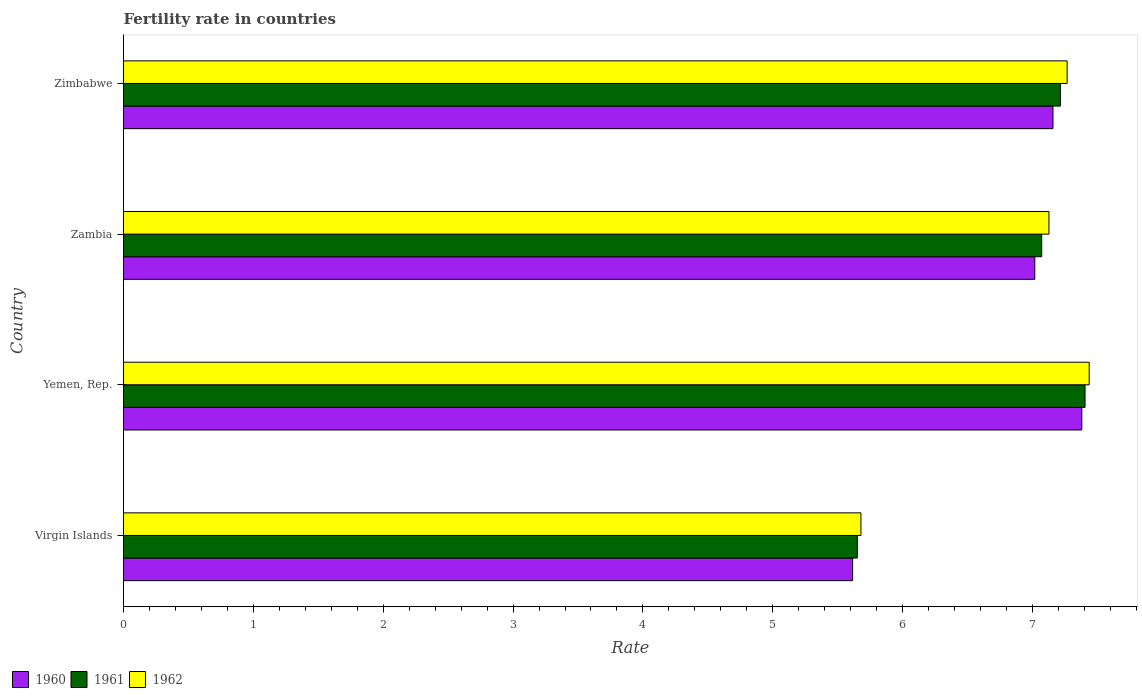How many different coloured bars are there?
Provide a short and direct response. 3. How many groups of bars are there?
Your answer should be compact. 4. Are the number of bars per tick equal to the number of legend labels?
Ensure brevity in your answer.  Yes. How many bars are there on the 4th tick from the top?
Your answer should be very brief. 3. How many bars are there on the 3rd tick from the bottom?
Keep it short and to the point. 3. What is the label of the 4th group of bars from the top?
Give a very brief answer. Virgin Islands. In how many cases, is the number of bars for a given country not equal to the number of legend labels?
Provide a short and direct response. 0. What is the fertility rate in 1962 in Yemen, Rep.?
Your response must be concise. 7.44. Across all countries, what is the maximum fertility rate in 1960?
Offer a terse response. 7.38. Across all countries, what is the minimum fertility rate in 1962?
Provide a succinct answer. 5.68. In which country was the fertility rate in 1961 maximum?
Your answer should be very brief. Yemen, Rep. In which country was the fertility rate in 1960 minimum?
Ensure brevity in your answer.  Virgin Islands. What is the total fertility rate in 1962 in the graph?
Provide a short and direct response. 27.51. What is the difference between the fertility rate in 1960 in Zambia and that in Zimbabwe?
Provide a short and direct response. -0.14. What is the difference between the fertility rate in 1962 in Virgin Islands and the fertility rate in 1960 in Zimbabwe?
Your answer should be compact. -1.48. What is the average fertility rate in 1960 per country?
Offer a very short reply. 6.79. What is the difference between the fertility rate in 1962 and fertility rate in 1960 in Virgin Islands?
Provide a succinct answer. 0.06. In how many countries, is the fertility rate in 1961 greater than 3.4 ?
Offer a terse response. 4. What is the ratio of the fertility rate in 1960 in Yemen, Rep. to that in Zimbabwe?
Your answer should be very brief. 1.03. Is the fertility rate in 1961 in Zambia less than that in Zimbabwe?
Your answer should be very brief. Yes. What is the difference between the highest and the second highest fertility rate in 1961?
Your answer should be compact. 0.19. What is the difference between the highest and the lowest fertility rate in 1961?
Provide a succinct answer. 1.75. In how many countries, is the fertility rate in 1961 greater than the average fertility rate in 1961 taken over all countries?
Your response must be concise. 3. What does the 3rd bar from the bottom in Yemen, Rep. represents?
Give a very brief answer. 1962. Is it the case that in every country, the sum of the fertility rate in 1960 and fertility rate in 1962 is greater than the fertility rate in 1961?
Give a very brief answer. Yes. Are all the bars in the graph horizontal?
Make the answer very short. Yes. Does the graph contain any zero values?
Keep it short and to the point. No. What is the title of the graph?
Make the answer very short. Fertility rate in countries. What is the label or title of the X-axis?
Make the answer very short. Rate. What is the label or title of the Y-axis?
Your response must be concise. Country. What is the Rate in 1960 in Virgin Islands?
Give a very brief answer. 5.62. What is the Rate in 1961 in Virgin Islands?
Your response must be concise. 5.65. What is the Rate of 1962 in Virgin Islands?
Ensure brevity in your answer.  5.68. What is the Rate in 1960 in Yemen, Rep.?
Your response must be concise. 7.38. What is the Rate in 1961 in Yemen, Rep.?
Ensure brevity in your answer.  7.41. What is the Rate of 1962 in Yemen, Rep.?
Make the answer very short. 7.44. What is the Rate in 1960 in Zambia?
Your response must be concise. 7.02. What is the Rate in 1961 in Zambia?
Provide a succinct answer. 7.07. What is the Rate in 1962 in Zambia?
Provide a short and direct response. 7.13. What is the Rate of 1960 in Zimbabwe?
Provide a succinct answer. 7.16. What is the Rate of 1961 in Zimbabwe?
Provide a short and direct response. 7.21. What is the Rate in 1962 in Zimbabwe?
Keep it short and to the point. 7.27. Across all countries, what is the maximum Rate of 1960?
Keep it short and to the point. 7.38. Across all countries, what is the maximum Rate of 1961?
Offer a very short reply. 7.41. Across all countries, what is the maximum Rate in 1962?
Provide a short and direct response. 7.44. Across all countries, what is the minimum Rate of 1960?
Provide a succinct answer. 5.62. Across all countries, what is the minimum Rate in 1961?
Keep it short and to the point. 5.65. Across all countries, what is the minimum Rate in 1962?
Provide a succinct answer. 5.68. What is the total Rate of 1960 in the graph?
Your answer should be compact. 27.17. What is the total Rate in 1961 in the graph?
Give a very brief answer. 27.34. What is the total Rate of 1962 in the graph?
Make the answer very short. 27.51. What is the difference between the Rate of 1960 in Virgin Islands and that in Yemen, Rep.?
Offer a very short reply. -1.76. What is the difference between the Rate of 1961 in Virgin Islands and that in Yemen, Rep.?
Provide a short and direct response. -1.75. What is the difference between the Rate of 1962 in Virgin Islands and that in Yemen, Rep.?
Give a very brief answer. -1.76. What is the difference between the Rate of 1960 in Virgin Islands and that in Zambia?
Give a very brief answer. -1.4. What is the difference between the Rate in 1961 in Virgin Islands and that in Zambia?
Provide a short and direct response. -1.42. What is the difference between the Rate of 1962 in Virgin Islands and that in Zambia?
Ensure brevity in your answer.  -1.45. What is the difference between the Rate in 1960 in Virgin Islands and that in Zimbabwe?
Your answer should be compact. -1.54. What is the difference between the Rate in 1961 in Virgin Islands and that in Zimbabwe?
Ensure brevity in your answer.  -1.56. What is the difference between the Rate in 1962 in Virgin Islands and that in Zimbabwe?
Keep it short and to the point. -1.59. What is the difference between the Rate of 1960 in Yemen, Rep. and that in Zambia?
Offer a very short reply. 0.36. What is the difference between the Rate in 1961 in Yemen, Rep. and that in Zambia?
Offer a terse response. 0.33. What is the difference between the Rate in 1962 in Yemen, Rep. and that in Zambia?
Offer a terse response. 0.31. What is the difference between the Rate in 1960 in Yemen, Rep. and that in Zimbabwe?
Provide a succinct answer. 0.22. What is the difference between the Rate in 1961 in Yemen, Rep. and that in Zimbabwe?
Your answer should be very brief. 0.19. What is the difference between the Rate in 1962 in Yemen, Rep. and that in Zimbabwe?
Offer a terse response. 0.17. What is the difference between the Rate of 1960 in Zambia and that in Zimbabwe?
Keep it short and to the point. -0.14. What is the difference between the Rate of 1961 in Zambia and that in Zimbabwe?
Your answer should be compact. -0.14. What is the difference between the Rate of 1962 in Zambia and that in Zimbabwe?
Ensure brevity in your answer.  -0.14. What is the difference between the Rate in 1960 in Virgin Islands and the Rate in 1961 in Yemen, Rep.?
Make the answer very short. -1.79. What is the difference between the Rate in 1960 in Virgin Islands and the Rate in 1962 in Yemen, Rep.?
Keep it short and to the point. -1.82. What is the difference between the Rate of 1961 in Virgin Islands and the Rate of 1962 in Yemen, Rep.?
Ensure brevity in your answer.  -1.79. What is the difference between the Rate in 1960 in Virgin Islands and the Rate in 1961 in Zambia?
Your response must be concise. -1.46. What is the difference between the Rate of 1960 in Virgin Islands and the Rate of 1962 in Zambia?
Your answer should be very brief. -1.51. What is the difference between the Rate of 1961 in Virgin Islands and the Rate of 1962 in Zambia?
Make the answer very short. -1.48. What is the difference between the Rate in 1960 in Virgin Islands and the Rate in 1962 in Zimbabwe?
Provide a succinct answer. -1.65. What is the difference between the Rate in 1961 in Virgin Islands and the Rate in 1962 in Zimbabwe?
Offer a very short reply. -1.62. What is the difference between the Rate of 1960 in Yemen, Rep. and the Rate of 1961 in Zambia?
Provide a short and direct response. 0.31. What is the difference between the Rate of 1960 in Yemen, Rep. and the Rate of 1962 in Zambia?
Offer a very short reply. 0.25. What is the difference between the Rate of 1961 in Yemen, Rep. and the Rate of 1962 in Zambia?
Your answer should be very brief. 0.28. What is the difference between the Rate of 1960 in Yemen, Rep. and the Rate of 1961 in Zimbabwe?
Give a very brief answer. 0.17. What is the difference between the Rate of 1960 in Yemen, Rep. and the Rate of 1962 in Zimbabwe?
Give a very brief answer. 0.11. What is the difference between the Rate of 1961 in Yemen, Rep. and the Rate of 1962 in Zimbabwe?
Your answer should be very brief. 0.14. What is the difference between the Rate of 1960 in Zambia and the Rate of 1961 in Zimbabwe?
Your answer should be very brief. -0.2. What is the difference between the Rate in 1960 in Zambia and the Rate in 1962 in Zimbabwe?
Provide a succinct answer. -0.25. What is the difference between the Rate of 1961 in Zambia and the Rate of 1962 in Zimbabwe?
Give a very brief answer. -0.2. What is the average Rate in 1960 per country?
Keep it short and to the point. 6.79. What is the average Rate of 1961 per country?
Provide a short and direct response. 6.84. What is the average Rate in 1962 per country?
Offer a very short reply. 6.88. What is the difference between the Rate of 1960 and Rate of 1961 in Virgin Islands?
Give a very brief answer. -0.04. What is the difference between the Rate in 1960 and Rate in 1962 in Virgin Islands?
Provide a succinct answer. -0.06. What is the difference between the Rate in 1961 and Rate in 1962 in Virgin Islands?
Ensure brevity in your answer.  -0.03. What is the difference between the Rate in 1960 and Rate in 1961 in Yemen, Rep.?
Make the answer very short. -0.03. What is the difference between the Rate in 1960 and Rate in 1962 in Yemen, Rep.?
Offer a very short reply. -0.06. What is the difference between the Rate of 1961 and Rate of 1962 in Yemen, Rep.?
Offer a terse response. -0.03. What is the difference between the Rate in 1960 and Rate in 1961 in Zambia?
Make the answer very short. -0.05. What is the difference between the Rate of 1960 and Rate of 1962 in Zambia?
Give a very brief answer. -0.11. What is the difference between the Rate of 1961 and Rate of 1962 in Zambia?
Give a very brief answer. -0.06. What is the difference between the Rate in 1960 and Rate in 1961 in Zimbabwe?
Your response must be concise. -0.06. What is the difference between the Rate of 1960 and Rate of 1962 in Zimbabwe?
Offer a very short reply. -0.11. What is the difference between the Rate of 1961 and Rate of 1962 in Zimbabwe?
Ensure brevity in your answer.  -0.05. What is the ratio of the Rate in 1960 in Virgin Islands to that in Yemen, Rep.?
Your response must be concise. 0.76. What is the ratio of the Rate in 1961 in Virgin Islands to that in Yemen, Rep.?
Give a very brief answer. 0.76. What is the ratio of the Rate of 1962 in Virgin Islands to that in Yemen, Rep.?
Give a very brief answer. 0.76. What is the ratio of the Rate of 1960 in Virgin Islands to that in Zambia?
Provide a succinct answer. 0.8. What is the ratio of the Rate of 1961 in Virgin Islands to that in Zambia?
Your answer should be very brief. 0.8. What is the ratio of the Rate in 1962 in Virgin Islands to that in Zambia?
Your response must be concise. 0.8. What is the ratio of the Rate in 1960 in Virgin Islands to that in Zimbabwe?
Keep it short and to the point. 0.78. What is the ratio of the Rate of 1961 in Virgin Islands to that in Zimbabwe?
Keep it short and to the point. 0.78. What is the ratio of the Rate in 1962 in Virgin Islands to that in Zimbabwe?
Offer a very short reply. 0.78. What is the ratio of the Rate in 1960 in Yemen, Rep. to that in Zambia?
Your answer should be compact. 1.05. What is the ratio of the Rate in 1961 in Yemen, Rep. to that in Zambia?
Offer a very short reply. 1.05. What is the ratio of the Rate of 1962 in Yemen, Rep. to that in Zambia?
Provide a short and direct response. 1.04. What is the ratio of the Rate of 1960 in Yemen, Rep. to that in Zimbabwe?
Keep it short and to the point. 1.03. What is the ratio of the Rate in 1961 in Yemen, Rep. to that in Zimbabwe?
Your response must be concise. 1.03. What is the ratio of the Rate in 1962 in Yemen, Rep. to that in Zimbabwe?
Give a very brief answer. 1.02. What is the ratio of the Rate of 1960 in Zambia to that in Zimbabwe?
Keep it short and to the point. 0.98. What is the ratio of the Rate in 1961 in Zambia to that in Zimbabwe?
Keep it short and to the point. 0.98. What is the ratio of the Rate of 1962 in Zambia to that in Zimbabwe?
Keep it short and to the point. 0.98. What is the difference between the highest and the second highest Rate in 1960?
Make the answer very short. 0.22. What is the difference between the highest and the second highest Rate in 1961?
Provide a succinct answer. 0.19. What is the difference between the highest and the second highest Rate in 1962?
Give a very brief answer. 0.17. What is the difference between the highest and the lowest Rate of 1960?
Provide a short and direct response. 1.76. What is the difference between the highest and the lowest Rate in 1961?
Your response must be concise. 1.75. What is the difference between the highest and the lowest Rate in 1962?
Your response must be concise. 1.76. 